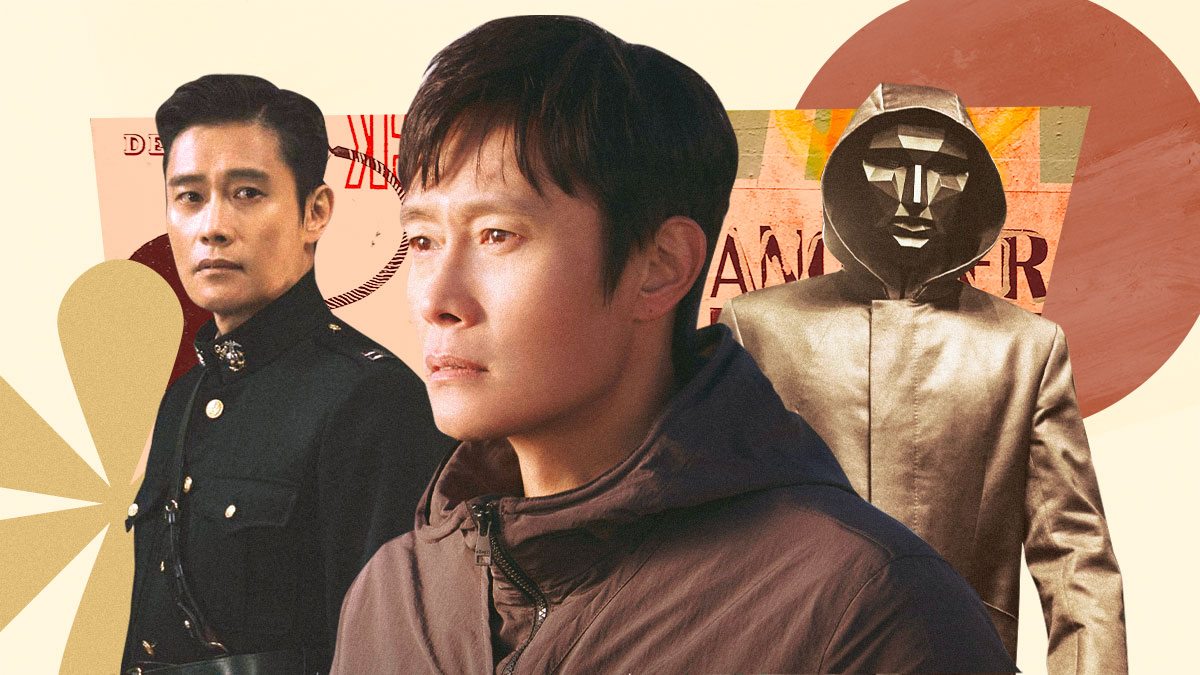Imagine that each character this actor is portraying is part of a single movie. What could be the possible plot? In a possible plot for a movie featuring these three characters, we might have a story of a man living a double life. By day, he is a respected military officer, upholding the law and maintaining order. However, by night, he becomes embroiled in a world of espionage and intrigue, donning a mask to conceal his identity while he navigates a dangerous underworld. In the midst of this, he struggles with his inner turmoil and moral conflicts, represented by his contemplative and casual persona that appears lost in thought. The film could explore themes of identity, duty, and the thin line between good and evil. 